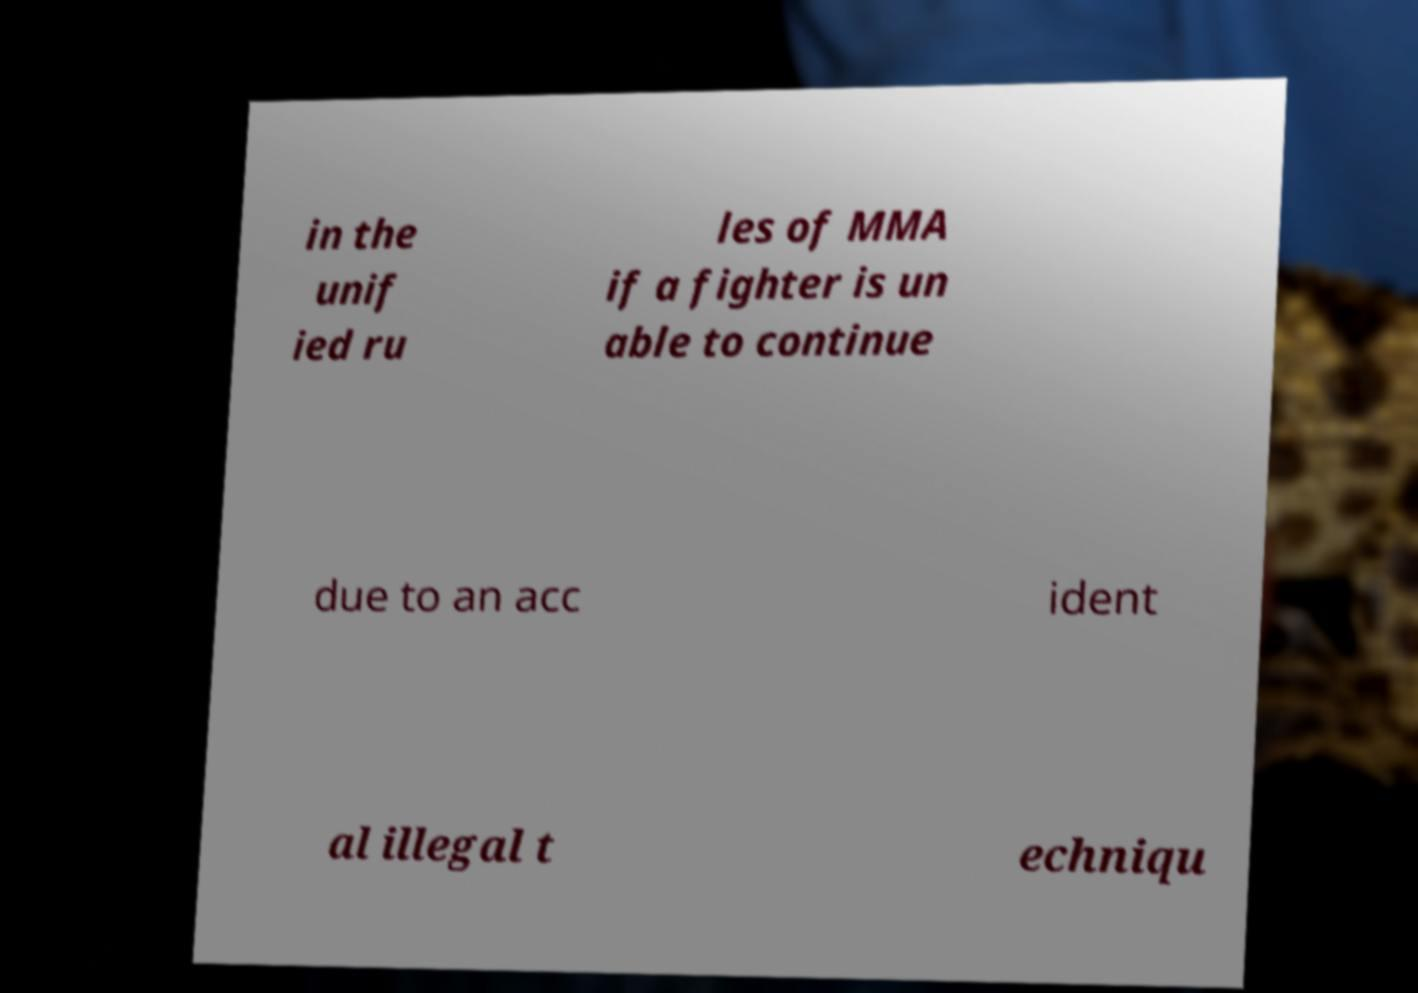Could you extract and type out the text from this image? in the unif ied ru les of MMA if a fighter is un able to continue due to an acc ident al illegal t echniqu 